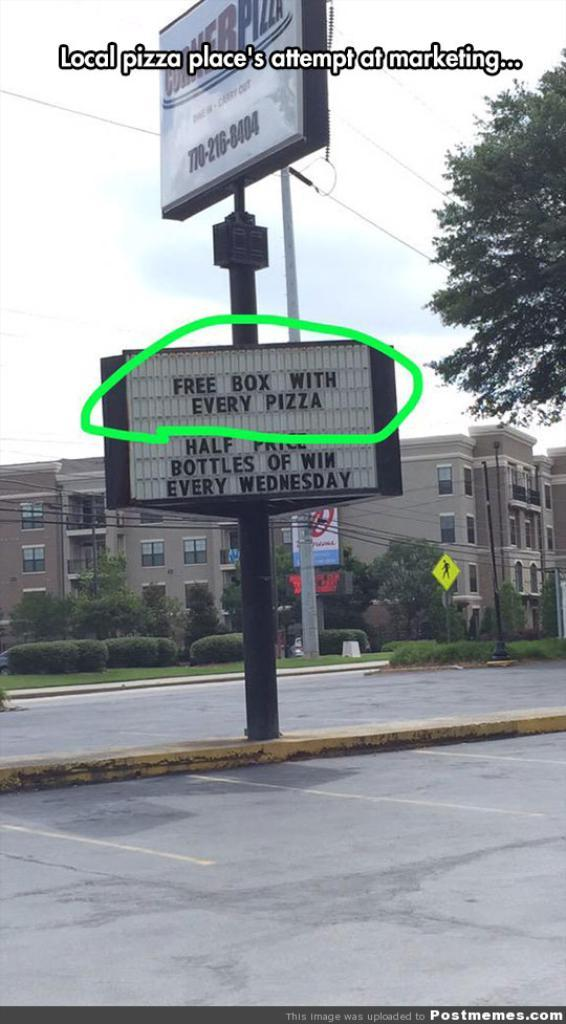<image>
Offer a succinct explanation of the picture presented. A sign talking about a local pizza place's marketing 